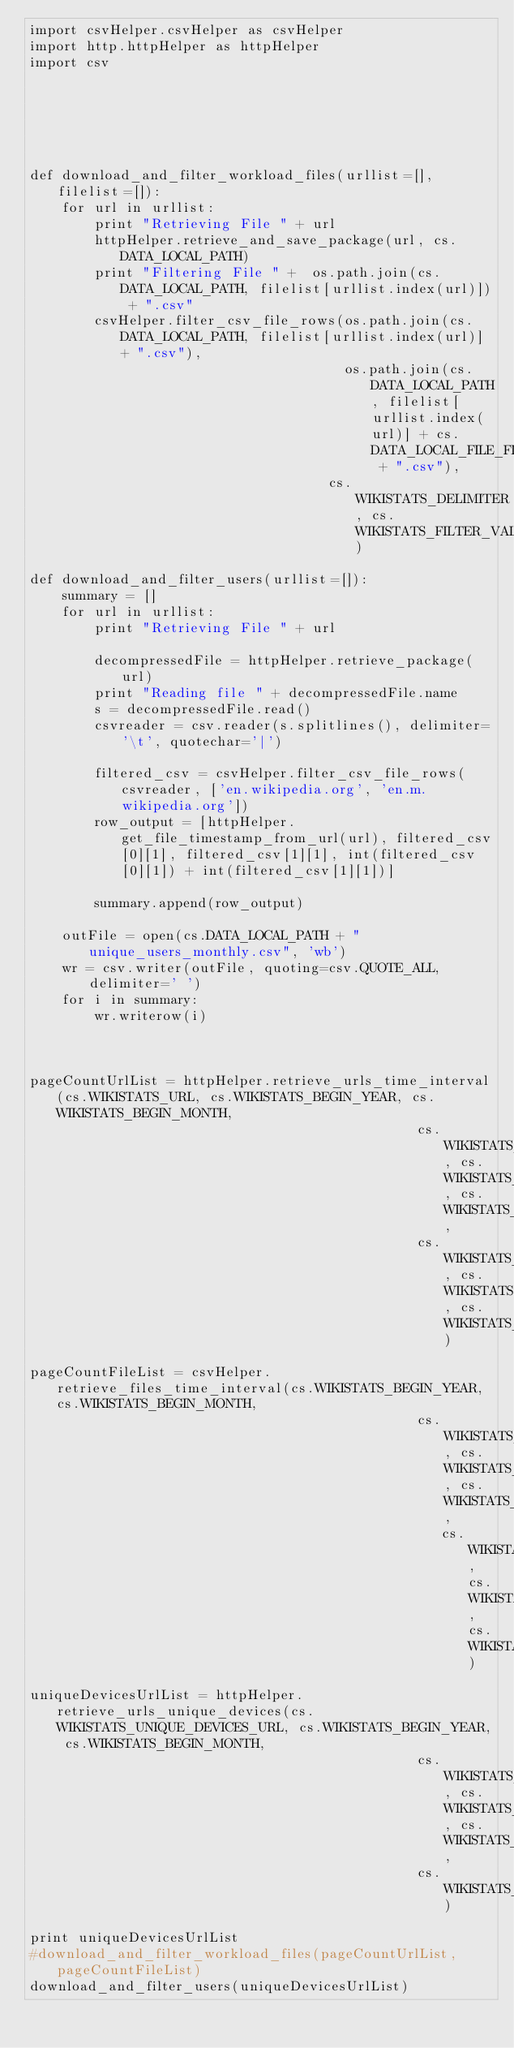Convert code to text. <code><loc_0><loc_0><loc_500><loc_500><_Python_>import csvHelper.csvHelper as csvHelper
import http.httpHelper as httpHelper
import csv






def download_and_filter_workload_files(urllist=[], filelist=[]):
    for url in urllist:
        print "Retrieving File " + url
        httpHelper.retrieve_and_save_package(url, cs.DATA_LOCAL_PATH)
        print "Filtering File " +  os.path.join(cs.DATA_LOCAL_PATH, filelist[urllist.index(url)]) + ".csv"
        csvHelper.filter_csv_file_rows(os.path.join(cs.DATA_LOCAL_PATH, filelist[urllist.index(url)] + ".csv"),
                                       os.path.join(cs.DATA_LOCAL_PATH, filelist[urllist.index(url)] + cs.DATA_LOCAL_FILE_FILTERED + ".csv"),
                                     cs.WIKISTATS_DELIMITER, cs.WIKISTATS_FILTER_VALUES)

def download_and_filter_users(urllist=[]):
    summary = []
    for url in urllist:
        print "Retrieving File " + url

        decompressedFile = httpHelper.retrieve_package(url)
        print "Reading file " + decompressedFile.name
        s = decompressedFile.read()
        csvreader = csv.reader(s.splitlines(), delimiter='\t', quotechar='|')

        filtered_csv = csvHelper.filter_csv_file_rows(csvreader, ['en.wikipedia.org', 'en.m.wikipedia.org'])
        row_output = [httpHelper.get_file_timestamp_from_url(url), filtered_csv[0][1], filtered_csv[1][1], int(filtered_csv[0][1]) + int(filtered_csv[1][1])]

        summary.append(row_output)

    outFile = open(cs.DATA_LOCAL_PATH + "unique_users_monthly.csv", 'wb')
    wr = csv.writer(outFile, quoting=csv.QUOTE_ALL, delimiter=' ')
    for i in summary:
        wr.writerow(i)



pageCountUrlList = httpHelper.retrieve_urls_time_interval(cs.WIKISTATS_URL, cs.WIKISTATS_BEGIN_YEAR, cs.WIKISTATS_BEGIN_MONTH,
                                                cs.WIKISTATS_BEGIN_DAY, cs.WIKISTATS_END_YEAR, cs.WIKISTATS_END_MONTH,
                                                cs.WIKISTATS_END_DAY, cs.WIKISTATS_HOURS, cs.WIKISTATS_PAGECOUNTS)

pageCountFileList = csvHelper.retrieve_files_time_interval(cs.WIKISTATS_BEGIN_YEAR, cs.WIKISTATS_BEGIN_MONTH,
                                                cs.WIKISTATS_BEGIN_DAY, cs.WIKISTATS_END_YEAR, cs.WIKISTATS_END_MONTH,
                                                   cs.WIKISTATS_END_DAY, cs.WIKISTATS_HOURS, cs.WIKISTATS_PAGECOUNTS)

uniqueDevicesUrlList = httpHelper.retrieve_urls_unique_devices(cs.WIKISTATS_UNIQUE_DEVICES_URL, cs.WIKISTATS_BEGIN_YEAR, cs.WIKISTATS_BEGIN_MONTH,
                                                cs.WIKISTATS_BEGIN_DAY, cs.WIKISTATS_END_YEAR, cs.WIKISTATS_END_MONTH,
                                                cs.WIKISTATS_END_DAY)

print uniqueDevicesUrlList
#download_and_filter_workload_files(pageCountUrlList, pageCountFileList)
download_and_filter_users(uniqueDevicesUrlList)

</code> 